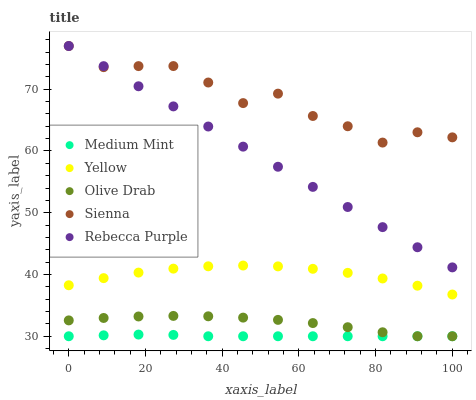Does Medium Mint have the minimum area under the curve?
Answer yes or no. Yes. Does Sienna have the maximum area under the curve?
Answer yes or no. Yes. Does Olive Drab have the minimum area under the curve?
Answer yes or no. No. Does Olive Drab have the maximum area under the curve?
Answer yes or no. No. Is Rebecca Purple the smoothest?
Answer yes or no. Yes. Is Sienna the roughest?
Answer yes or no. Yes. Is Olive Drab the smoothest?
Answer yes or no. No. Is Olive Drab the roughest?
Answer yes or no. No. Does Medium Mint have the lowest value?
Answer yes or no. Yes. Does Sienna have the lowest value?
Answer yes or no. No. Does Rebecca Purple have the highest value?
Answer yes or no. Yes. Does Olive Drab have the highest value?
Answer yes or no. No. Is Olive Drab less than Yellow?
Answer yes or no. Yes. Is Rebecca Purple greater than Olive Drab?
Answer yes or no. Yes. Does Olive Drab intersect Medium Mint?
Answer yes or no. Yes. Is Olive Drab less than Medium Mint?
Answer yes or no. No. Is Olive Drab greater than Medium Mint?
Answer yes or no. No. Does Olive Drab intersect Yellow?
Answer yes or no. No. 